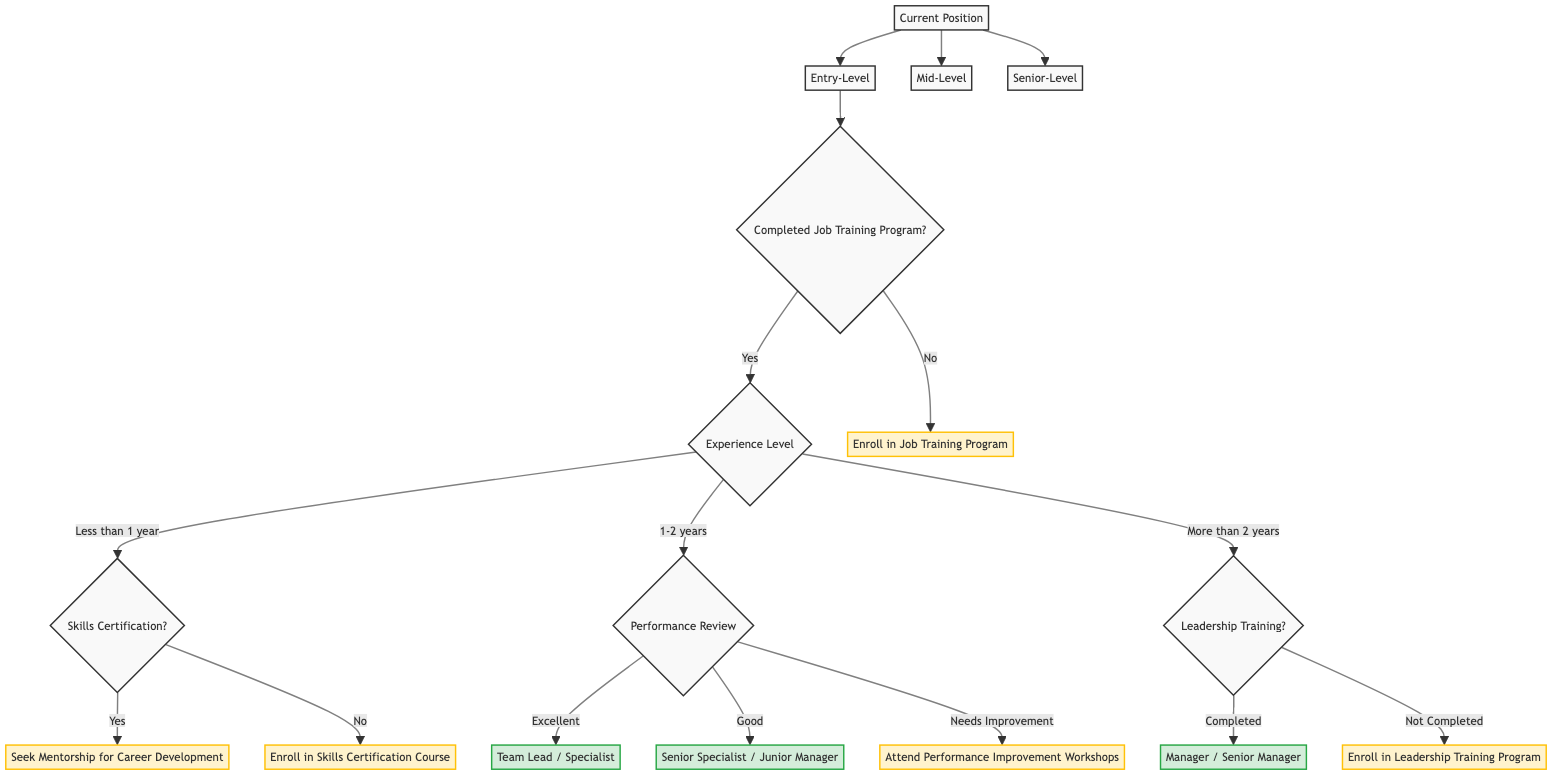What are the three types of current positions in this diagram? The diagram indicates three types of current positions that an individual can hold: Entry-Level, Mid-Level, and Senior-Level.
Answer: Entry-Level, Mid-Level, Senior-Level What should someone in the Entry-Level group do if they have not completed the job training program? According to the diagram, if a person is in the Entry-Level category and has not completed the job training program, they should enroll in the job training program.
Answer: Enroll in Job Training Program What are the three experience levels listed under the Entry-Level node? The diagram outlines three experience levels within the Entry-Level node: Less than 1 year, 1-2 years, and More than 2 years.
Answer: Less than 1 year, 1-2 years, More than 2 years If someone has more than 2 years of experience and has not completed leadership training, what should they do? For individuals in the diagram with more than 2 years of experience who have not completed leadership training, the suggested action is to enroll in the leadership training program.
Answer: Enroll in Leadership Training Program What promotion paths are suggested for those with a performance review rated as Excellent? Individuals with an Excellent performance review can be promoted to either Team Lead or Specialist, as stated in the diagram.
Answer: Team Lead, Specialist What is the promotion possibility for someone with 1-2 years of experience and a Good performance review? According to the diagram, if a person has 1-2 years of experience and a Good performance review, the promotion possibility is categorized as Medium.
Answer: Medium How many nodes are directly connected to the Entry-Level node? The diagram shows that the Entry-Level node has three directly connected nodes: Completed Job Training Program, Experience Level, and Enroll in Job Training Program, totaling to three nodes.
Answer: 3 What action is suggested for Entry-Level individuals with less than 1 year of experience who do not have skills certification? For those with less than 1 year of experience without skills certification, the recommended action is to enroll in a skills certification course, according to the diagram.
Answer: Enroll in Skills Certification Course If a Senior-Level employee has completed leadership training, what are their promotion paths? The diagram indicates that if a Senior-Level employee has completed leadership training, they can be promoted to either Manager or Senior Manager.
Answer: Manager, Senior Manager 